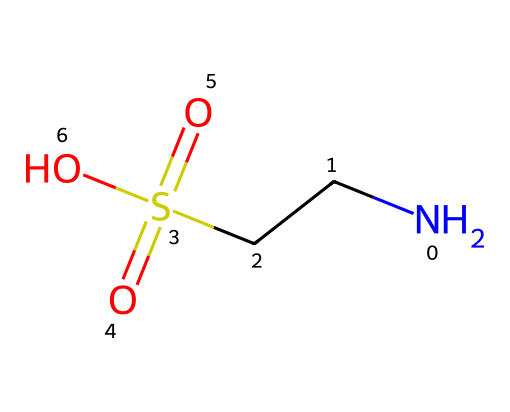What is the molecular formula of taurine? To find the molecular formula, count the number of each type of atom in the structure. There are two nitrogen atoms, four carbon atoms, and six oxygen atoms in the given SMILES, leading to the empirical formula being C2H7N1O6S1.
Answer: C2H7NO6S How many sulfur atoms are present in taurine? By examining the SMILES representation, we can see that there is one 'S' character in the structure. This indicates that there is one sulfur atom present.
Answer: one What functional groups are present in taurine? Based on the SMILES notation, taurine contains a sulfonic acid group (-S(=O)(=O)O), as well as an amine group (-NH2) from the nitrogen atom. Hence, we identify these two functional groups.
Answer: sulfonic acid and amine What is the pH nature of taurine? Taurine is a sulfonic acid, and such compounds typically exhibit acidic properties in solution. This indicates that the pH of taurine is likely to be below 7.
Answer: acidic What is the significance of the sulfonic acid group in taurine? The sulfonic acid group (-S(=O)(=O)O) contributes to the solubility of taurine in water and provides it with a strong acidic property, which is crucial for its physiological role in the human body.
Answer: solubility and acidity Is taurine an organosulfur compound? Yes, taurine contains a sulfur atom as part of its sulfonic acid functional group, which defines it as an organosulfur compound.
Answer: yes 